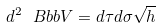<formula> <loc_0><loc_0><loc_500><loc_500>d ^ { 2 } { \ B b b V } = d \tau d \sigma \sqrt { h }</formula> 